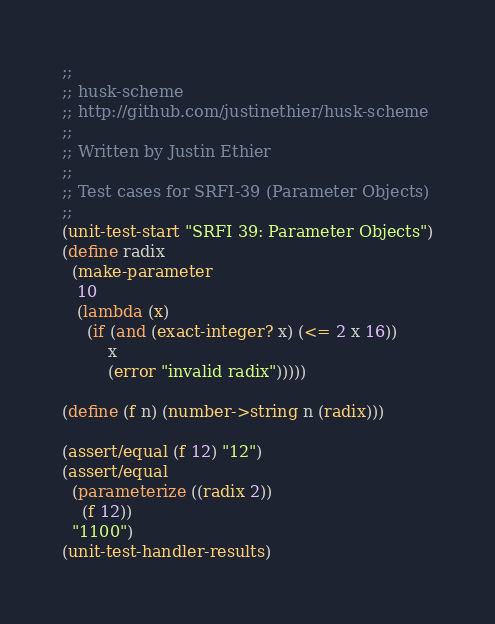Convert code to text. <code><loc_0><loc_0><loc_500><loc_500><_Scheme_>;;
;; husk-scheme
;; http://github.com/justinethier/husk-scheme
;;
;; Written by Justin Ethier
;;
;; Test cases for SRFI-39 (Parameter Objects)
;;
(unit-test-start "SRFI 39: Parameter Objects")
(define radix
  (make-parameter
   10
   (lambda (x)
     (if (and (exact-integer? x) (<= 2 x 16))
         x
         (error "invalid radix")))))

(define (f n) (number->string n (radix)))

(assert/equal (f 12) "12")
(assert/equal
  (parameterize ((radix 2)) 
    (f 12)) 
  "1100")
(unit-test-handler-results)
</code> 